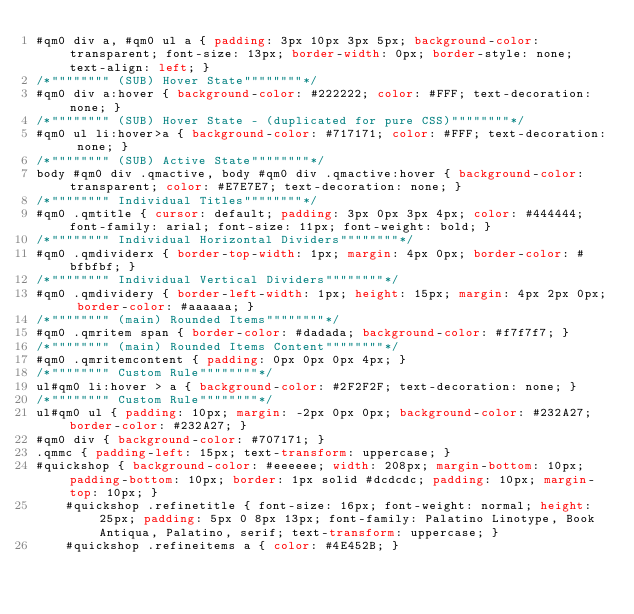<code> <loc_0><loc_0><loc_500><loc_500><_CSS_>#qm0 div a, #qm0 ul a { padding: 3px 10px 3px 5px; background-color: transparent; font-size: 13px; border-width: 0px; border-style: none; text-align: left; }
/*"""""""" (SUB) Hover State""""""""*/
#qm0 div a:hover { background-color: #222222; color: #FFF; text-decoration: none; }
/*"""""""" (SUB) Hover State - (duplicated for pure CSS)""""""""*/
#qm0 ul li:hover>a { background-color: #717171; color: #FFF; text-decoration: none; }
/*"""""""" (SUB) Active State""""""""*/
body #qm0 div .qmactive, body #qm0 div .qmactive:hover { background-color: transparent; color: #E7E7E7; text-decoration: none; }
/*"""""""" Individual Titles""""""""*/
#qm0 .qmtitle { cursor: default; padding: 3px 0px 3px 4px; color: #444444; font-family: arial; font-size: 11px; font-weight: bold; }
/*"""""""" Individual Horizontal Dividers""""""""*/
#qm0 .qmdividerx { border-top-width: 1px; margin: 4px 0px; border-color: #bfbfbf; }
/*"""""""" Individual Vertical Dividers""""""""*/
#qm0 .qmdividery { border-left-width: 1px; height: 15px; margin: 4px 2px 0px; border-color: #aaaaaa; }
/*"""""""" (main) Rounded Items""""""""*/
#qm0 .qmritem span { border-color: #dadada; background-color: #f7f7f7; }
/*"""""""" (main) Rounded Items Content""""""""*/
#qm0 .qmritemcontent { padding: 0px 0px 0px 4px; }
/*"""""""" Custom Rule""""""""*/
ul#qm0 li:hover > a { background-color: #2F2F2F; text-decoration: none; }
/*"""""""" Custom Rule""""""""*/
ul#qm0 ul { padding: 10px; margin: -2px 0px 0px; background-color: #232A27; border-color: #232A27; }
#qm0 div { background-color: #707171; }
.qmmc { padding-left: 15px; text-transform: uppercase; }
#quickshop { background-color: #eeeeee; width: 208px; margin-bottom: 10px; padding-bottom: 10px; border: 1px solid #dcdcdc; padding: 10px; margin-top: 10px; }
	#quickshop .refinetitle { font-size: 16px; font-weight: normal; height: 25px; padding: 5px 0 8px 13px; font-family: Palatino Linotype, Book Antiqua, Palatino, serif; text-transform: uppercase; }
	#quickshop .refineitems a { color: #4E452B; }</code> 